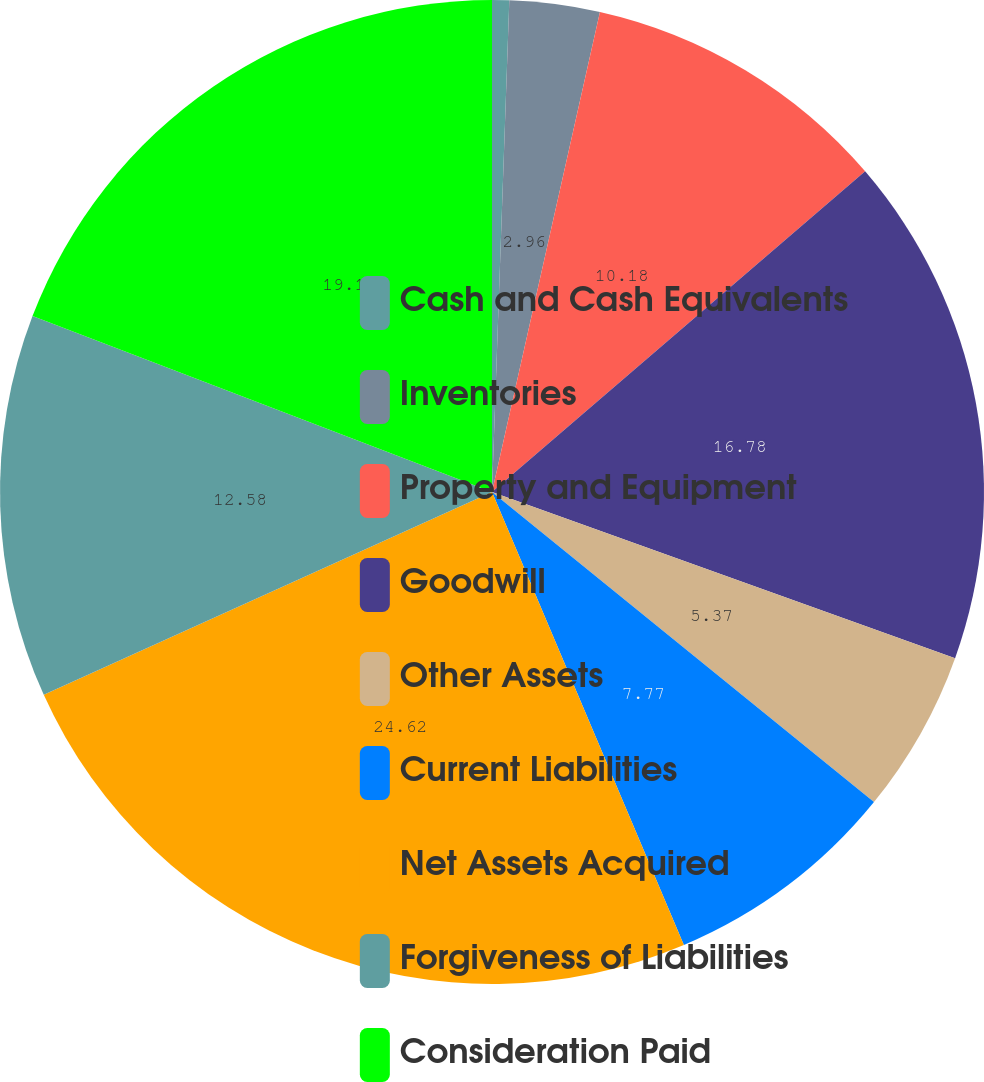<chart> <loc_0><loc_0><loc_500><loc_500><pie_chart><fcel>Cash and Cash Equivalents<fcel>Inventories<fcel>Property and Equipment<fcel>Goodwill<fcel>Other Assets<fcel>Current Liabilities<fcel>Net Assets Acquired<fcel>Forgiveness of Liabilities<fcel>Consideration Paid<nl><fcel>0.56%<fcel>2.96%<fcel>10.18%<fcel>16.78%<fcel>5.37%<fcel>7.77%<fcel>24.61%<fcel>12.58%<fcel>19.18%<nl></chart> 